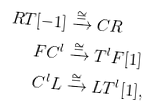Convert formula to latex. <formula><loc_0><loc_0><loc_500><loc_500>R T [ - 1 ] & \xrightarrow \cong C R \\ F C ^ { l } & \xrightarrow \cong T ^ { l } F [ 1 ] \\ C ^ { l } L & \xrightarrow \cong L T ^ { l } [ 1 ] ,</formula> 